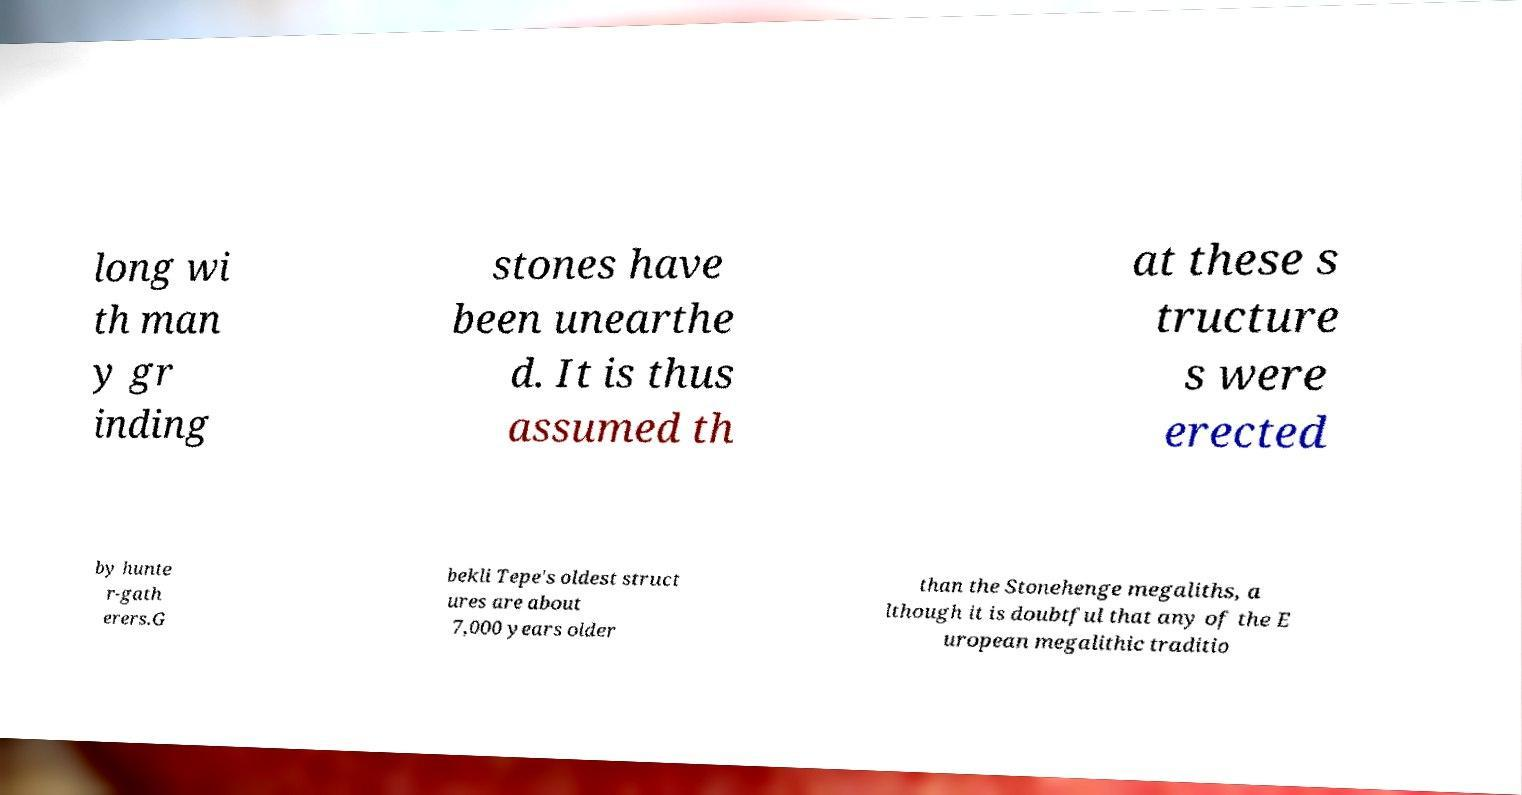For documentation purposes, I need the text within this image transcribed. Could you provide that? long wi th man y gr inding stones have been unearthe d. It is thus assumed th at these s tructure s were erected by hunte r-gath erers.G bekli Tepe's oldest struct ures are about 7,000 years older than the Stonehenge megaliths, a lthough it is doubtful that any of the E uropean megalithic traditio 